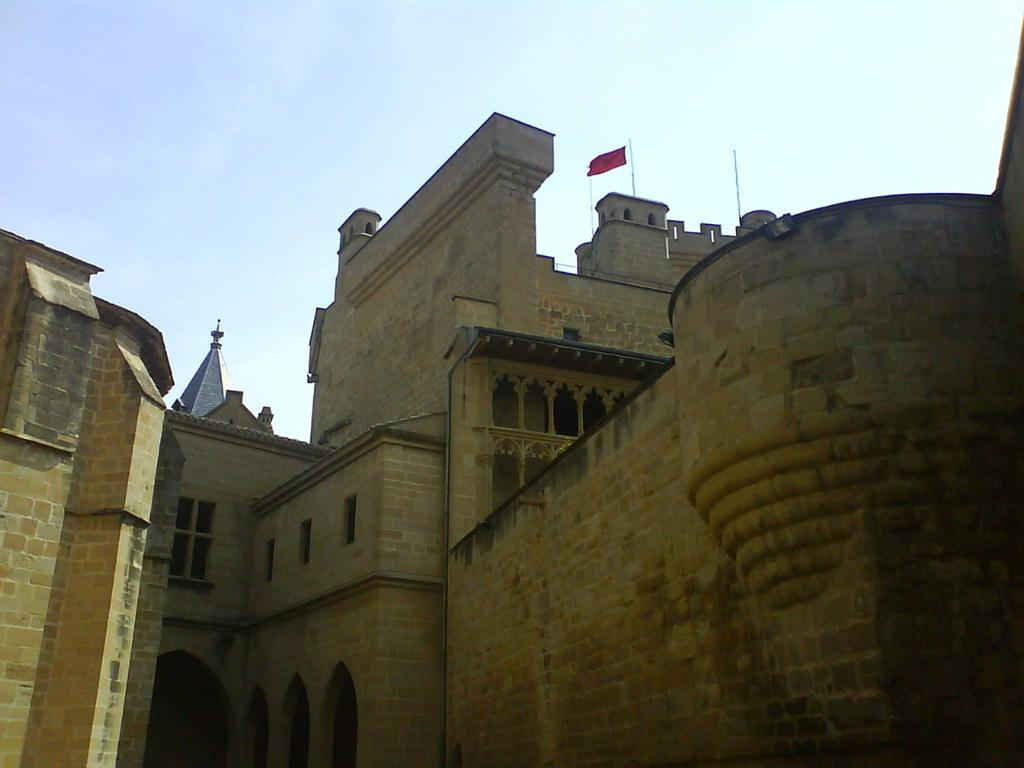What is the main structure in the picture? There is a building in the picture. What is attached to the building? The building has a flag and poles on it. What can be seen in the background of the picture? The sky is visible in the background of the picture. How many stars can be seen on the flag in the image? There is no flag with stars present in the image; the flag has a solid color. What level of security clearance does the spy have in the image? There is no spy present in the image; it features a building with a flag and poles. 